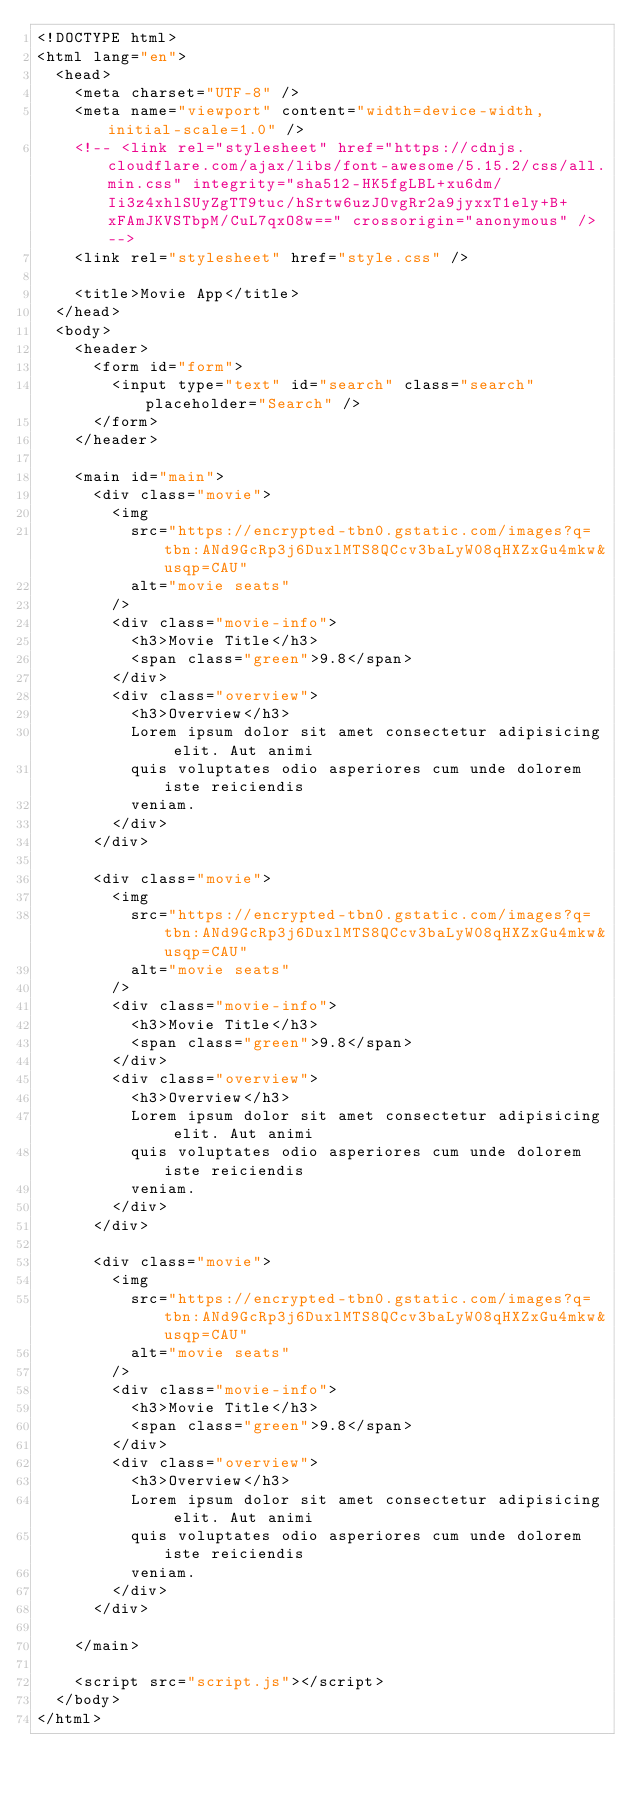<code> <loc_0><loc_0><loc_500><loc_500><_HTML_><!DOCTYPE html>
<html lang="en">
  <head>
    <meta charset="UTF-8" />
    <meta name="viewport" content="width=device-width, initial-scale=1.0" />
    <!-- <link rel="stylesheet" href="https://cdnjs.cloudflare.com/ajax/libs/font-awesome/5.15.2/css/all.min.css" integrity="sha512-HK5fgLBL+xu6dm/Ii3z4xhlSUyZgTT9tuc/hSrtw6uzJOvgRr2a9jyxxT1ely+B+xFAmJKVSTbpM/CuL7qxO8w==" crossorigin="anonymous" /> -->
    <link rel="stylesheet" href="style.css" />

    <title>Movie App</title>
  </head>
  <body>
    <header>
      <form id="form">
        <input type="text" id="search" class="search" placeholder="Search" />
      </form>
    </header>

    <main id="main">
      <div class="movie">
        <img
          src="https://encrypted-tbn0.gstatic.com/images?q=tbn:ANd9GcRp3j6DuxlMTS8QCcv3baLyW08qHXZxGu4mkw&usqp=CAU"
          alt="movie seats"
        />
        <div class="movie-info">
          <h3>Movie Title</h3>
          <span class="green">9.8</span>
        </div>
        <div class="overview">
          <h3>Overview</h3>
          Lorem ipsum dolor sit amet consectetur adipisicing elit. Aut animi
          quis voluptates odio asperiores cum unde dolorem iste reiciendis
          veniam.
        </div>
      </div>

      <div class="movie">
        <img
          src="https://encrypted-tbn0.gstatic.com/images?q=tbn:ANd9GcRp3j6DuxlMTS8QCcv3baLyW08qHXZxGu4mkw&usqp=CAU"
          alt="movie seats"
        />
        <div class="movie-info">
          <h3>Movie Title</h3>
          <span class="green">9.8</span>
        </div>
        <div class="overview">
          <h3>Overview</h3>
          Lorem ipsum dolor sit amet consectetur adipisicing elit. Aut animi
          quis voluptates odio asperiores cum unde dolorem iste reiciendis
          veniam.
        </div>
      </div>

      <div class="movie">
        <img
          src="https://encrypted-tbn0.gstatic.com/images?q=tbn:ANd9GcRp3j6DuxlMTS8QCcv3baLyW08qHXZxGu4mkw&usqp=CAU"
          alt="movie seats"
        />
        <div class="movie-info">
          <h3>Movie Title</h3>
          <span class="green">9.8</span>
        </div>
        <div class="overview">
          <h3>Overview</h3>
          Lorem ipsum dolor sit amet consectetur adipisicing elit. Aut animi
          quis voluptates odio asperiores cum unde dolorem iste reiciendis
          veniam.
        </div>
      </div>
      
    </main>

    <script src="script.js"></script>
  </body>
</html>
</code> 